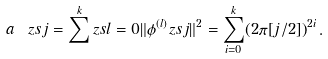Convert formula to latex. <formula><loc_0><loc_0><loc_500><loc_500>a _ { \ } z s { j } = \sum ^ { k } _ { \ } z s { l = 0 } \| \phi ^ { ( l ) } _ { \ } z s { j } \| ^ { 2 } = \sum ^ { k } _ { i = 0 } ( 2 \pi [ j / 2 ] ) ^ { 2 i } \, .</formula> 